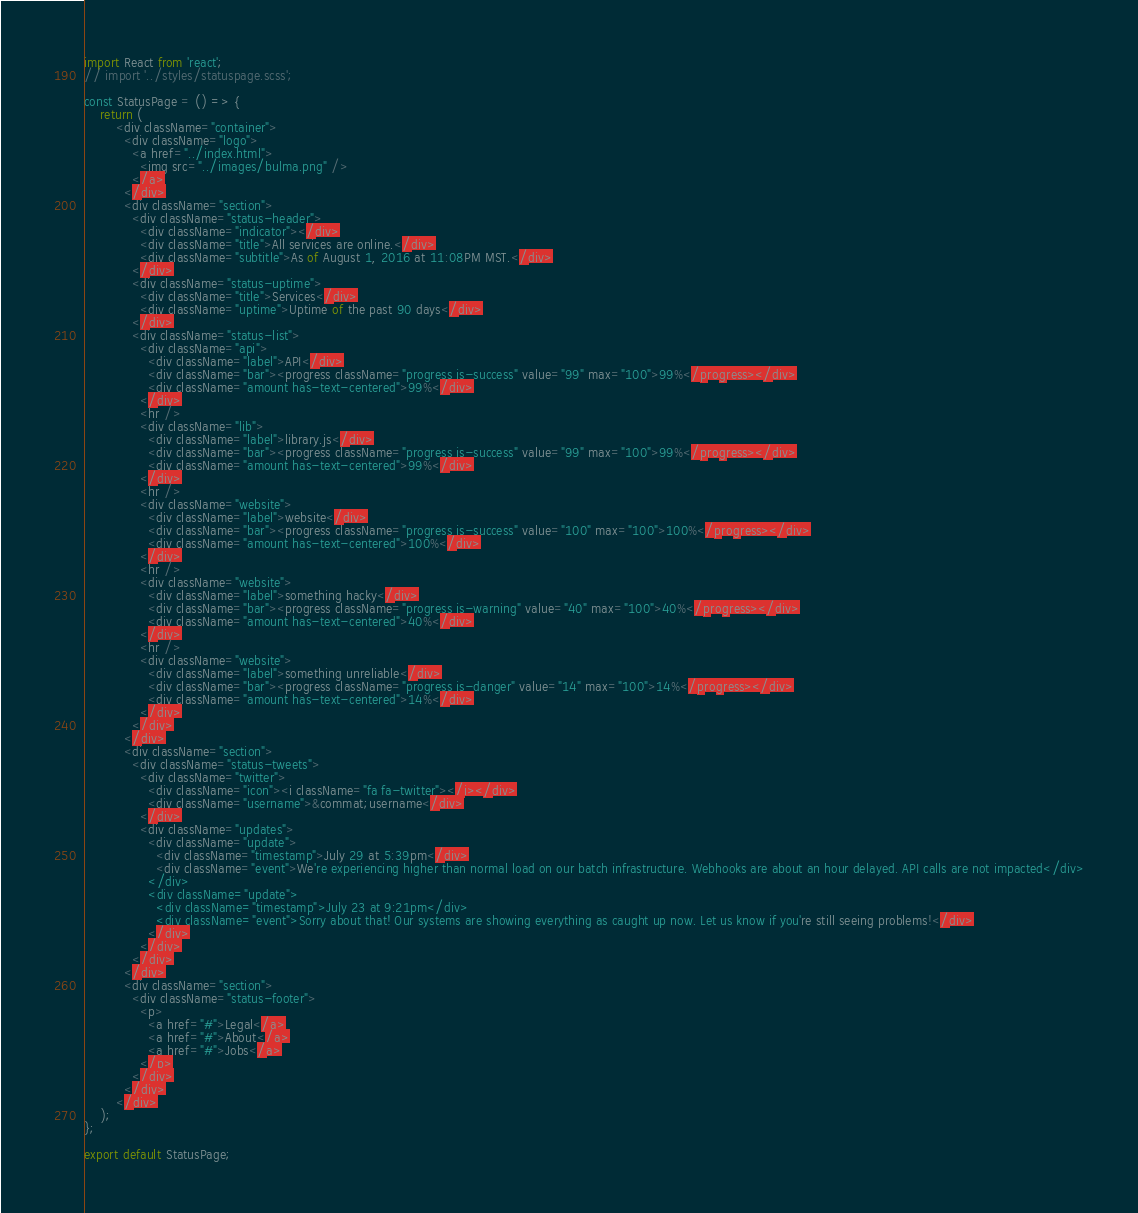<code> <loc_0><loc_0><loc_500><loc_500><_JavaScript_>import React from 'react';
// import '../styles/statuspage.scss';

const StatusPage = () => {
    return (
        <div className="container">
          <div className="logo">
            <a href="../index.html">
              <img src="../images/bulma.png" />
            </a>
          </div>
          <div className="section">
            <div className="status-header">
              <div className="indicator"></div>
              <div className="title">All services are online.</div>
              <div className="subtitle">As of August 1, 2016 at 11:08PM MST.</div>
            </div>
            <div className="status-uptime">
              <div className="title">Services</div>
              <div className="uptime">Uptime of the past 90 days</div>
            </div>
            <div className="status-list">
              <div className="api">
                <div className="label">API</div>
                <div className="bar"><progress className="progress is-success" value="99" max="100">99%</progress></div>
                <div className="amount has-text-centered">99%</div>
              </div>
              <hr />
              <div className="lib">
                <div className="label">library.js</div>
                <div className="bar"><progress className="progress is-success" value="99" max="100">99%</progress></div>
                <div className="amount has-text-centered">99%</div>
              </div>
              <hr />
              <div className="website">
                <div className="label">website</div>
                <div className="bar"><progress className="progress is-success" value="100" max="100">100%</progress></div>
                <div className="amount has-text-centered">100%</div>
              </div>
              <hr />
              <div className="website">
                <div className="label">something hacky</div>
                <div className="bar"><progress className="progress is-warning" value="40" max="100">40%</progress></div>
                <div className="amount has-text-centered">40%</div>
              </div>
              <hr />
              <div className="website">
                <div className="label">something unreliable</div>
                <div className="bar"><progress className="progress is-danger" value="14" max="100">14%</progress></div>
                <div className="amount has-text-centered">14%</div>
              </div>
            </div>
          </div>
          <div className="section">
            <div className="status-tweets">
              <div className="twitter">
                <div className="icon"><i className="fa fa-twitter"></i></div>
                <div className="username">&commat;username</div>
              </div>
              <div className="updates">
                <div className="update">
                  <div className="timestamp">July 29 at 5:39pm</div>
                  <div className="event">We're experiencing higher than normal load on our batch infrastructure. Webhooks are about an hour delayed. API calls are not impacted</div>
                </div>
                <div className="update">
                  <div className="timestamp">July 23 at 9:21pm</div>
                  <div className="event">Sorry about that! Our systems are showing everything as caught up now. Let us know if you're still seeing problems!</div>
                </div>
              </div>
            </div>
          </div>
          <div className="section">
            <div className="status-footer">
              <p>
                <a href="#">Legal</a>
                <a href="#">About</a>
                <a href="#">Jobs</a>
              </p>
            </div>
          </div>
        </div>
    );
};

export default StatusPage;
</code> 